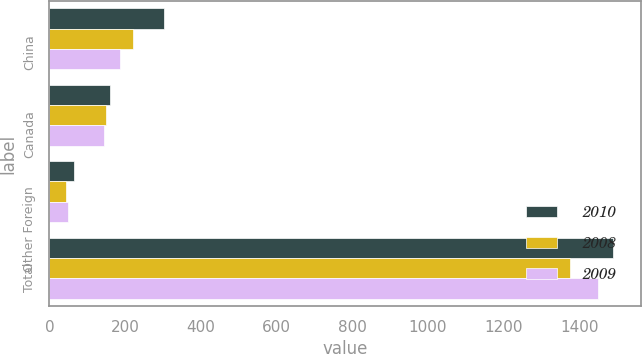<chart> <loc_0><loc_0><loc_500><loc_500><stacked_bar_chart><ecel><fcel>China<fcel>Canada<fcel>Other Foreign<fcel>Total<nl><fcel>2010<fcel>304.4<fcel>160.4<fcel>64.1<fcel>1489.3<nl><fcel>2008<fcel>222<fcel>150.4<fcel>43.6<fcel>1375<nl><fcel>2009<fcel>186.5<fcel>143.6<fcel>48.3<fcel>1451.3<nl></chart> 